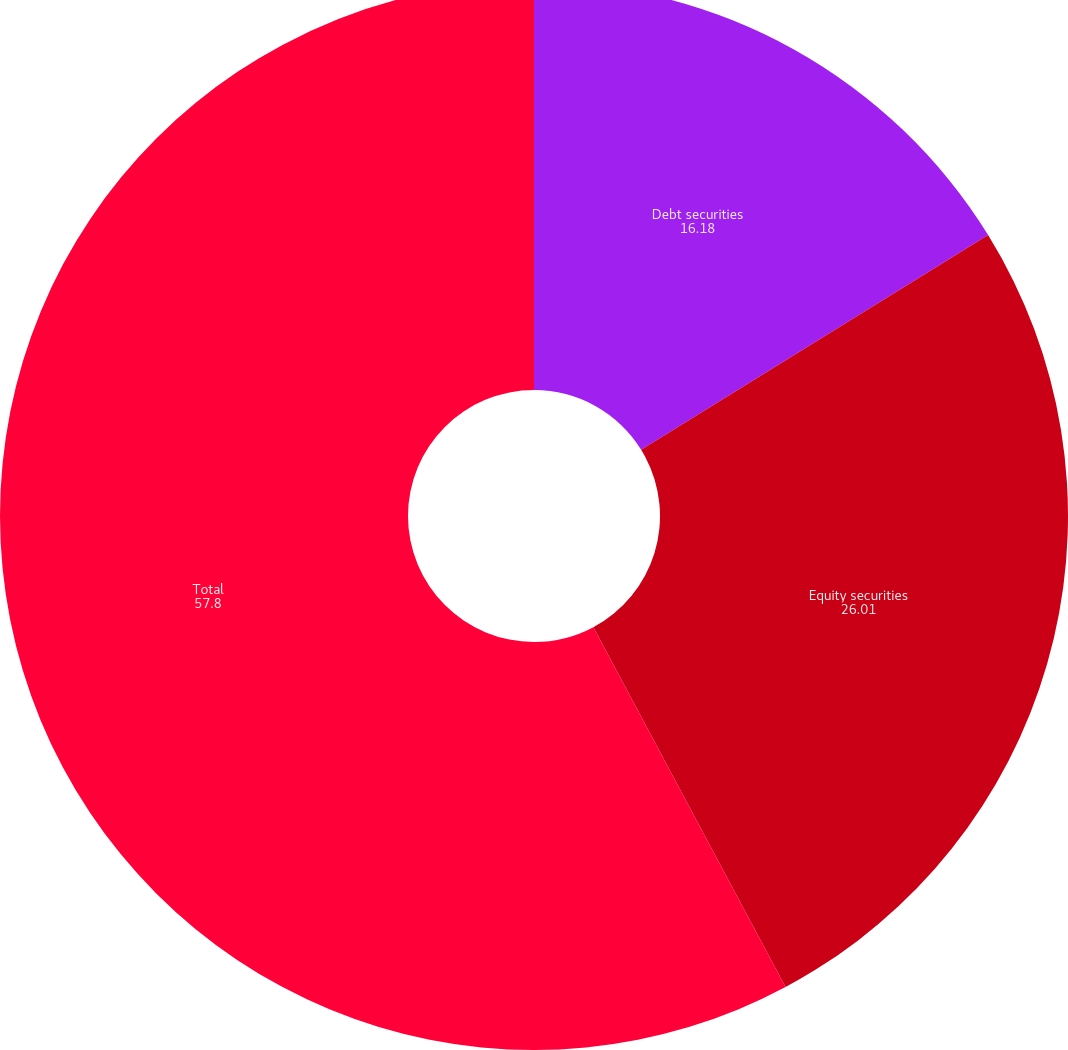Convert chart. <chart><loc_0><loc_0><loc_500><loc_500><pie_chart><fcel>Debt securities<fcel>Equity securities<fcel>Total<nl><fcel>16.18%<fcel>26.01%<fcel>57.8%<nl></chart> 